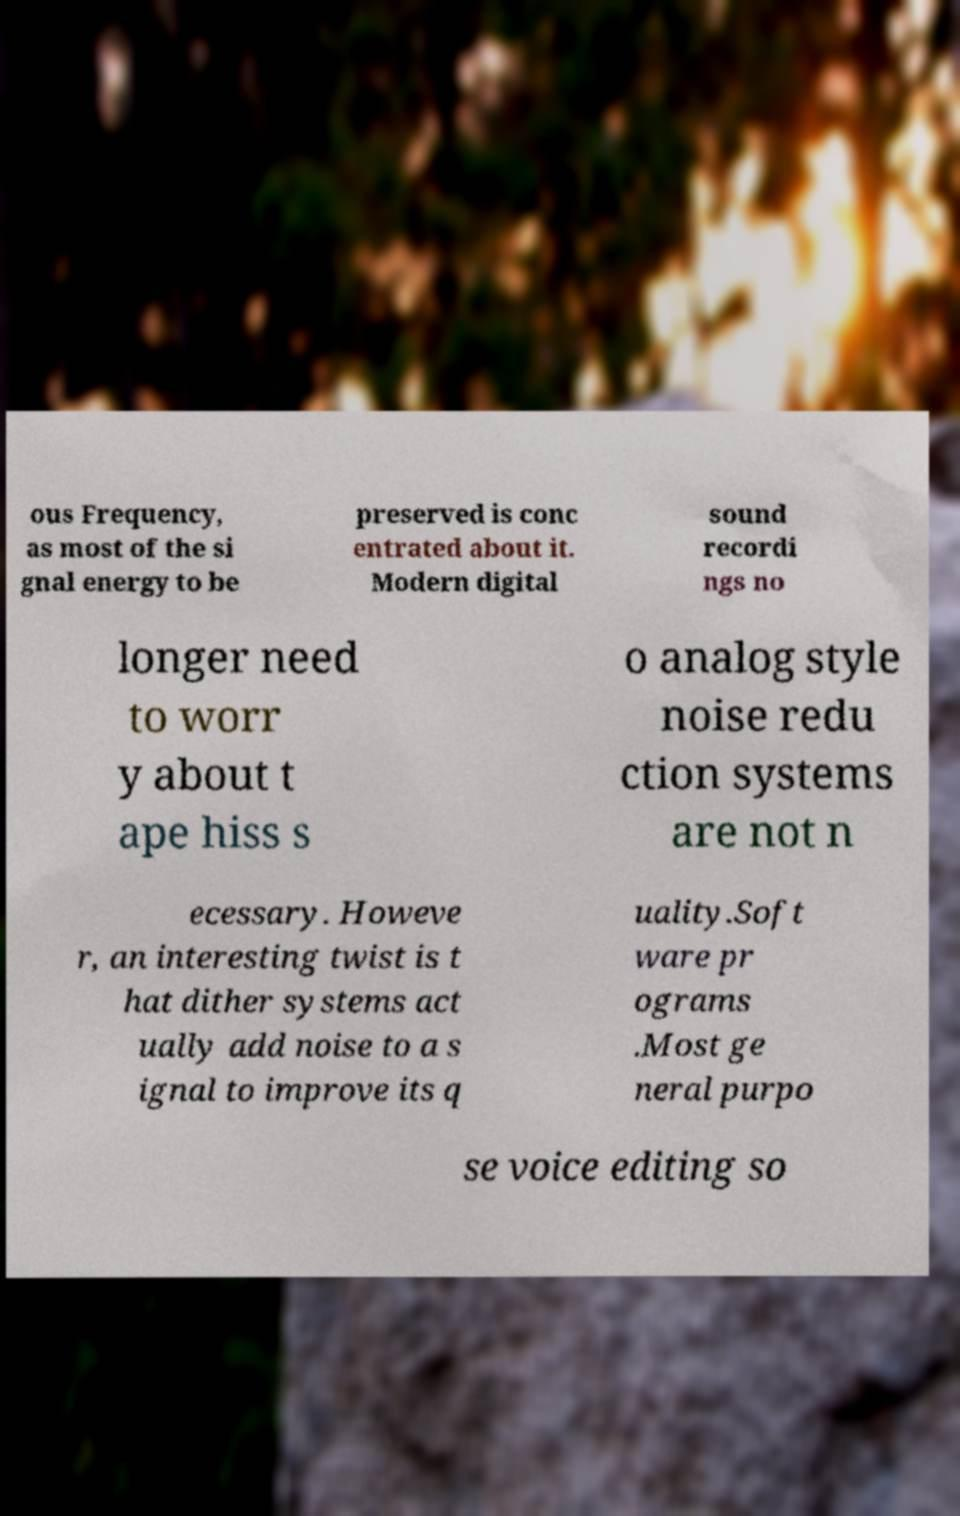Please read and relay the text visible in this image. What does it say? ous Frequency, as most of the si gnal energy to be preserved is conc entrated about it. Modern digital sound recordi ngs no longer need to worr y about t ape hiss s o analog style noise redu ction systems are not n ecessary. Howeve r, an interesting twist is t hat dither systems act ually add noise to a s ignal to improve its q uality.Soft ware pr ograms .Most ge neral purpo se voice editing so 